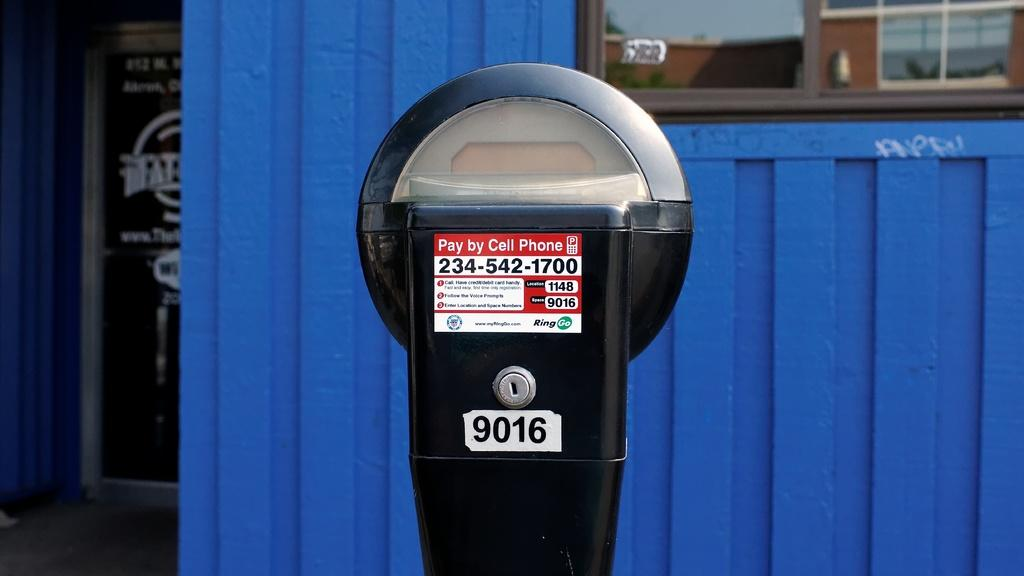What type of cell phone is visible in the image? There is a pay bill cell phone in the image. What is located behind the cell phone? There is a wall in the image. What can be seen through the window in the image? The window has a reflection of trees and the sky. What type of store is visible in the image? There is no store visible in the image. What songs can be heard playing in the background of the image? There is no audio or indication of songs in the image. 